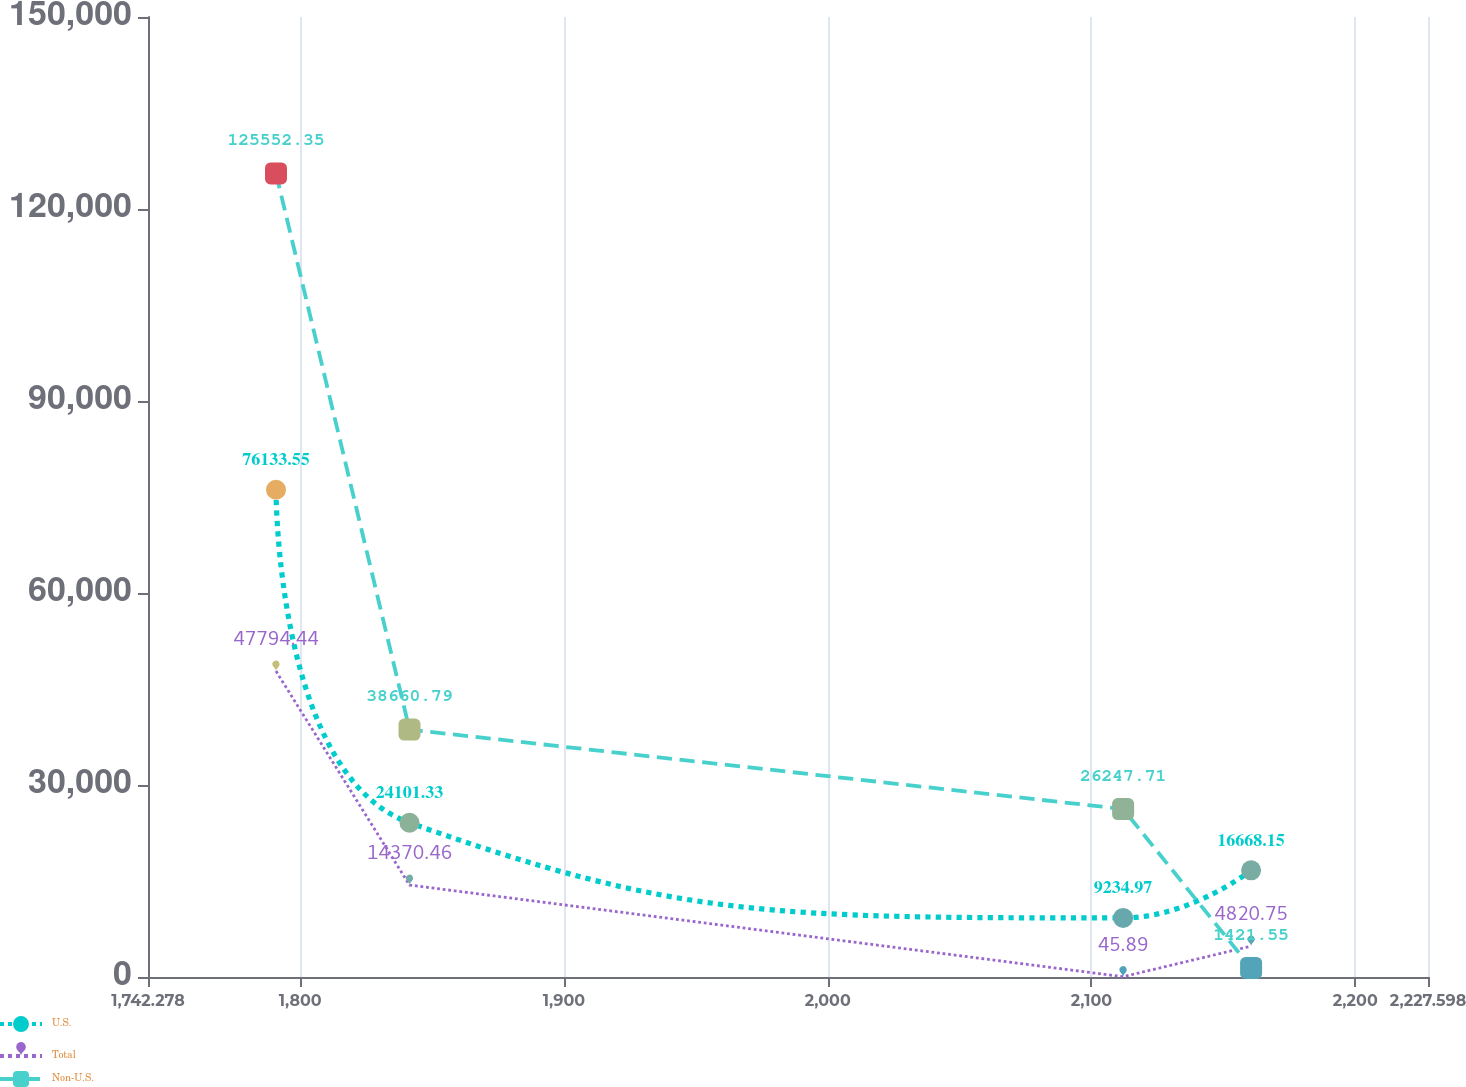<chart> <loc_0><loc_0><loc_500><loc_500><line_chart><ecel><fcel>U.S.<fcel>Total<fcel>Non-U.S.<nl><fcel>1790.81<fcel>76133.6<fcel>47794.4<fcel>125552<nl><fcel>1841.43<fcel>24101.3<fcel>14370.5<fcel>38660.8<nl><fcel>2112<fcel>9234.97<fcel>45.89<fcel>26247.7<nl><fcel>2160.53<fcel>16668.2<fcel>4820.75<fcel>1421.55<nl><fcel>2276.13<fcel>1801.79<fcel>9595.6<fcel>13834.6<nl></chart> 